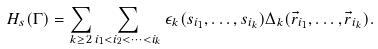Convert formula to latex. <formula><loc_0><loc_0><loc_500><loc_500>H _ { s } ( \Gamma ) = \sum _ { k \geq 2 } \sum _ { i _ { 1 } < i _ { 2 } < \dots < i _ { k } } \epsilon _ { k } ( s _ { i _ { 1 } } , \dots , s _ { i _ { k } } ) \Delta _ { k } ( \vec { r } _ { i _ { 1 } } , \dots , \vec { r } _ { i _ { k } } ) .</formula> 